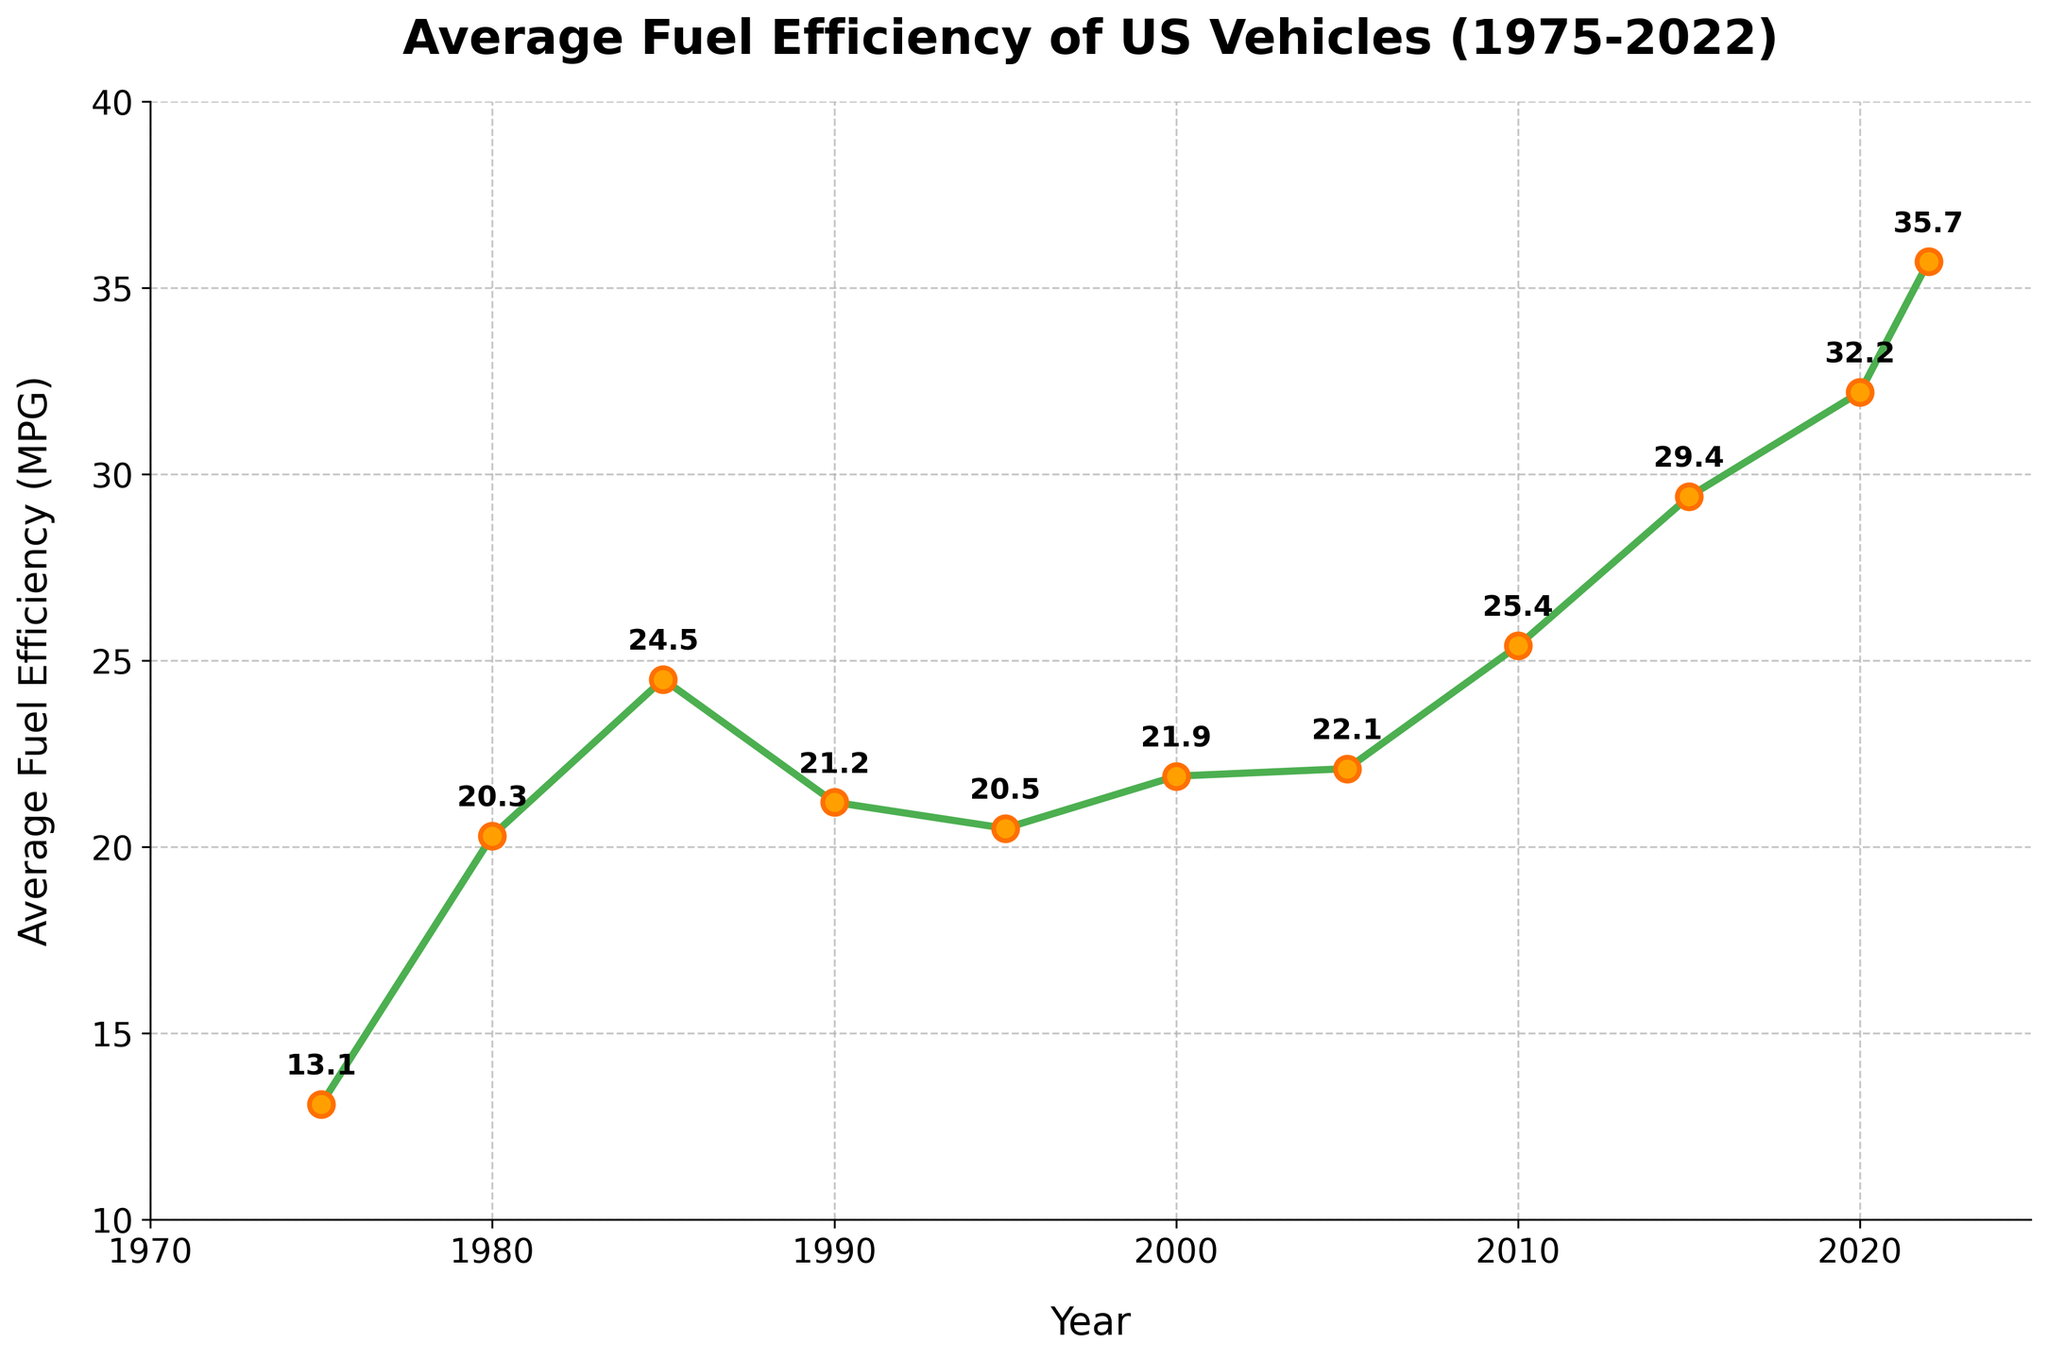What is the general trend in average fuel efficiency from 1975 to 2022? The general trend in the average fuel efficiency of US vehicles from 1975 to 2022 is an overall increase. Despite some decreases in certain years, the efficiency has improved from 13.1 MPG in 1975 to 35.7 MPG in 2022.
Answer: An overall increase Did average fuel efficiency increase or decrease between 1985 and 1990? By looking at the data points and the plot, average fuel efficiency decreased from 24.5 MPG in 1985 to 21.2 MPG in 1990.
Answer: Decrease Which year experienced the highest average fuel efficiency? From the data and the plotted line, the year 2022 experienced the highest average fuel efficiency at 35.7 MPG.
Answer: 2022 How does the average fuel efficiency in 2010 compare to that in 2000? The average fuel efficiency in 2010 (25.4 MPG) is higher than the one in 2000 (21.9 MPG).
Answer: Higher What is the difference in average fuel efficiency between the years 1975 and 2022? The average fuel efficiency in 2022 is 35.7 MPG and in 1975 it was 13.1 MPG. The difference is calculated as 35.7 - 13.1 = 22.6 MPG.
Answer: 22.6 MPG What was the average fuel efficiency in 1985, and how does it compare to 1995? The average fuel efficiency in 1985 was 24.5 MPG, and in 1995 it was 20.5 MPG. Therefore, in 1985 it was higher by 24.5 - 20.5 = 4 MPG.
Answer: 4 MPG higher in 1985 In which decade did the largest increase in fuel efficiency occur? To find the largest increase, we compare the differences over each decade. From 1975 to 1985: 24.5 - 13.1 = 11.4 MPG, from 1985 to 1995: 20.5 - 24.5 = -4 MPG (decrease), from 1995 to 2005: 22.1 - 20.5 = 1.6 MPG, from 2005 to 2015: 29.4 - 22.1 = 7.3 MPG, and from 2012 to 2022: 35.7 - 25.4 = 10.3 MPG. The largest increase was from 1975 to 1985.
Answer: 1975 to 1985 In which years did the average fuel efficiency see a drop? By examining the figure and data, the years which saw a drop in fuel efficiency are between 1985 and 1990 (24.5 to 21.2 MPG) and between 1990 and 1995 (21.2 to 20.5 MPG).
Answer: Between 1985-1990 and 1990-1995 What is the average fuel efficiency for the years 2000, 2005, and 2010? To find the average, add up the values for these years and divide by 3. So, (21.9 + 22.1 + 25.4)/3 = 69.4/3 = 23.13 MPG
Answer: 23.13 MPG What are the visual characteristics used to highlight the data points? The visual characteristics include using markers ('o') with a size of 10, line width of 3, green color for the line, orange filling for the markers, and thicker dark orange marker edges.
Answer: Markers with specific color and size 